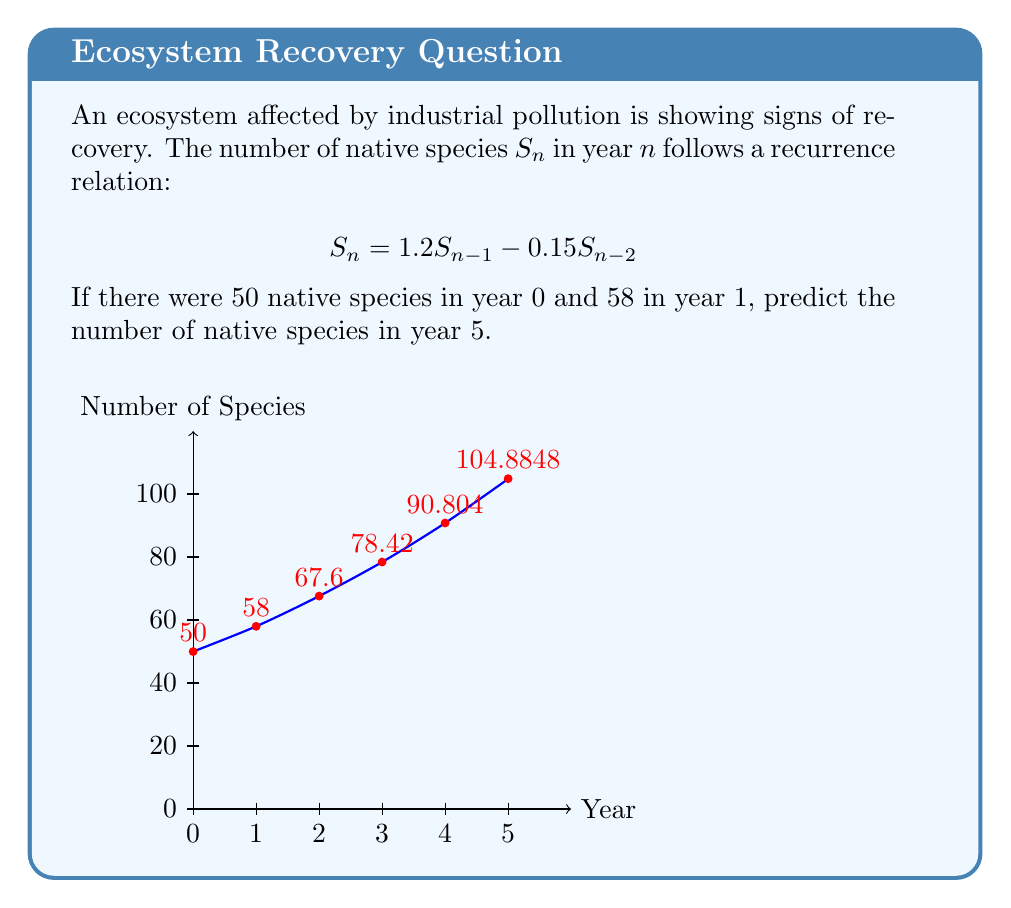Give your solution to this math problem. Let's approach this step-by-step:

1) We are given the recurrence relation: $S_n = 1.2S_{n-1} - 0.15S_{n-2}$

2) We know the initial conditions:
   $S_0 = 50$
   $S_1 = 58$

3) Let's calculate the subsequent years:

   For $n = 2$:
   $S_2 = 1.2S_1 - 0.15S_0$
   $S_2 = 1.2(58) - 0.15(50) = 69.6 - 7.5 = 62.1$

   For $n = 3$:
   $S_3 = 1.2S_2 - 0.15S_1$
   $S_3 = 1.2(62.1) - 0.15(58) = 74.52 - 8.7 = 65.82$

   For $n = 4$:
   $S_4 = 1.2S_3 - 0.15S_2$
   $S_4 = 1.2(65.82) - 0.15(62.1) = 78.984 - 9.315 = 69.669$

   For $n = 5$:
   $S_5 = 1.2S_4 - 0.15S_3$
   $S_5 = 1.2(69.669) - 0.15(65.82) = 83.6028 - 9.873 = 73.7298$

4) Therefore, the predicted number of native species in year 5 is approximately 73.73.
Answer: 73.73 species 